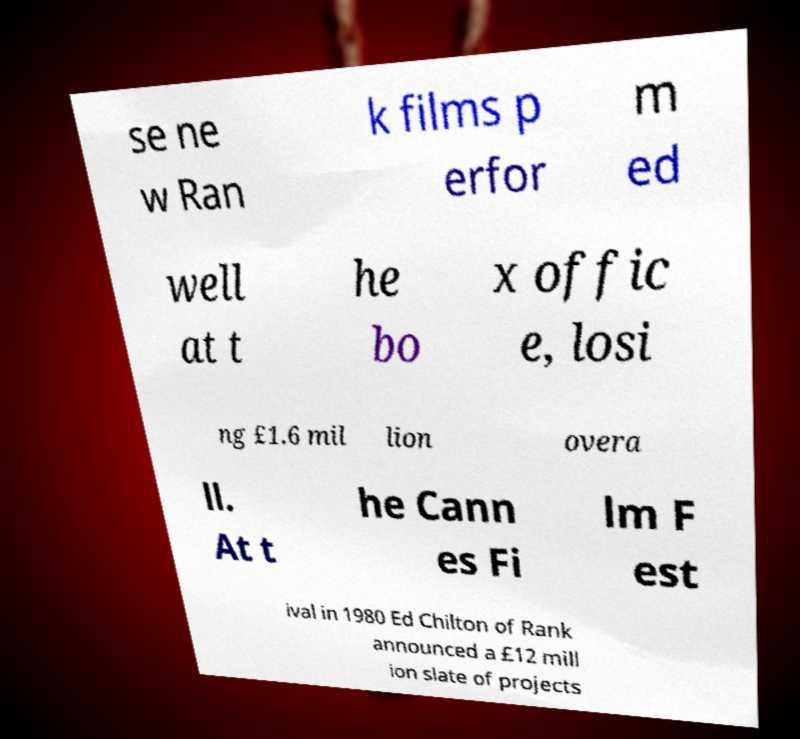What messages or text are displayed in this image? I need them in a readable, typed format. se ne w Ran k films p erfor m ed well at t he bo x offic e, losi ng £1.6 mil lion overa ll. At t he Cann es Fi lm F est ival in 1980 Ed Chilton of Rank announced a £12 mill ion slate of projects 